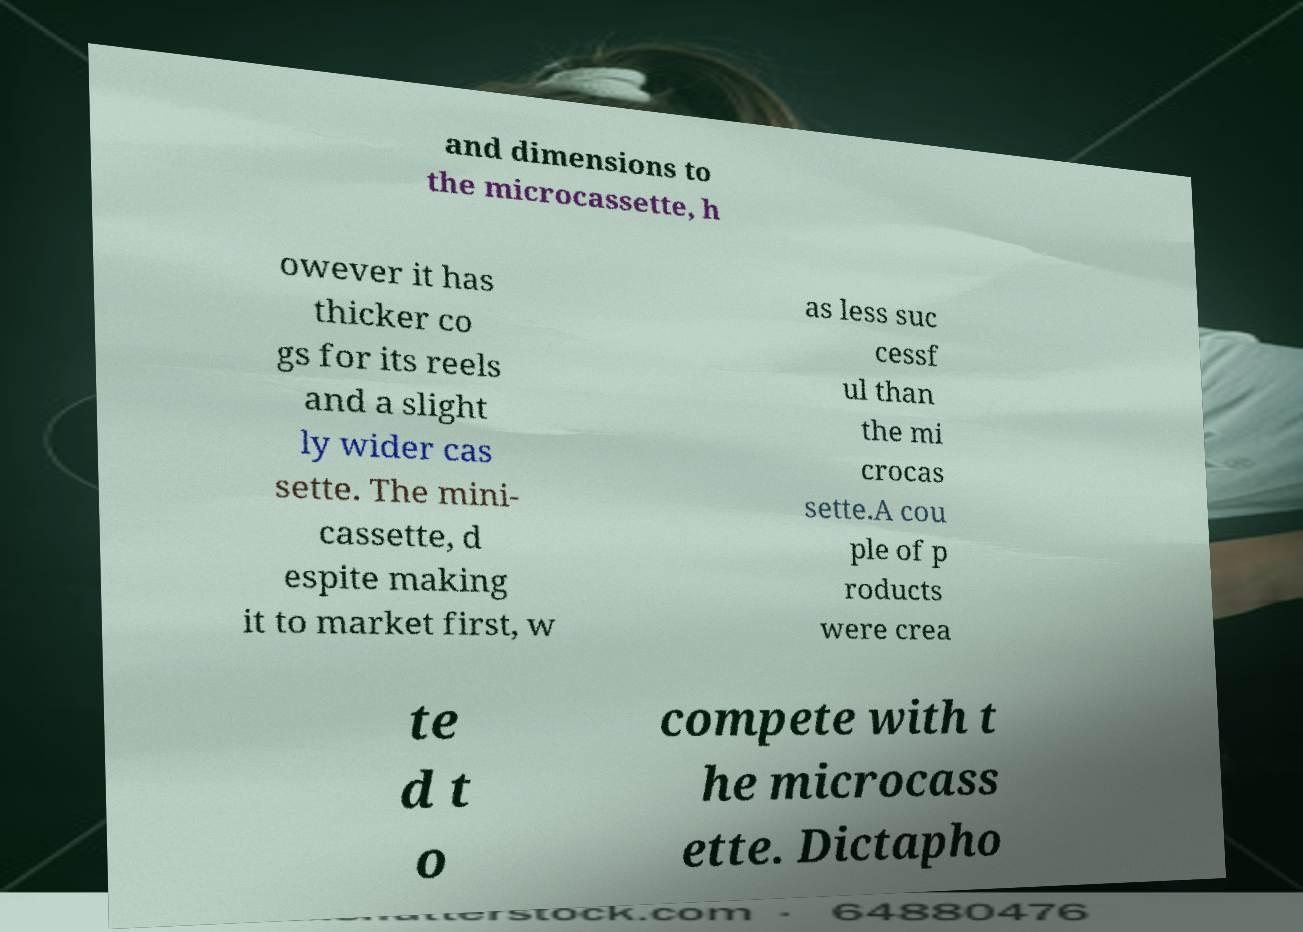Please identify and transcribe the text found in this image. and dimensions to the microcassette, h owever it has thicker co gs for its reels and a slight ly wider cas sette. The mini- cassette, d espite making it to market first, w as less suc cessf ul than the mi crocas sette.A cou ple of p roducts were crea te d t o compete with t he microcass ette. Dictapho 